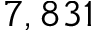Convert formula to latex. <formula><loc_0><loc_0><loc_500><loc_500>7 , 8 3 1</formula> 